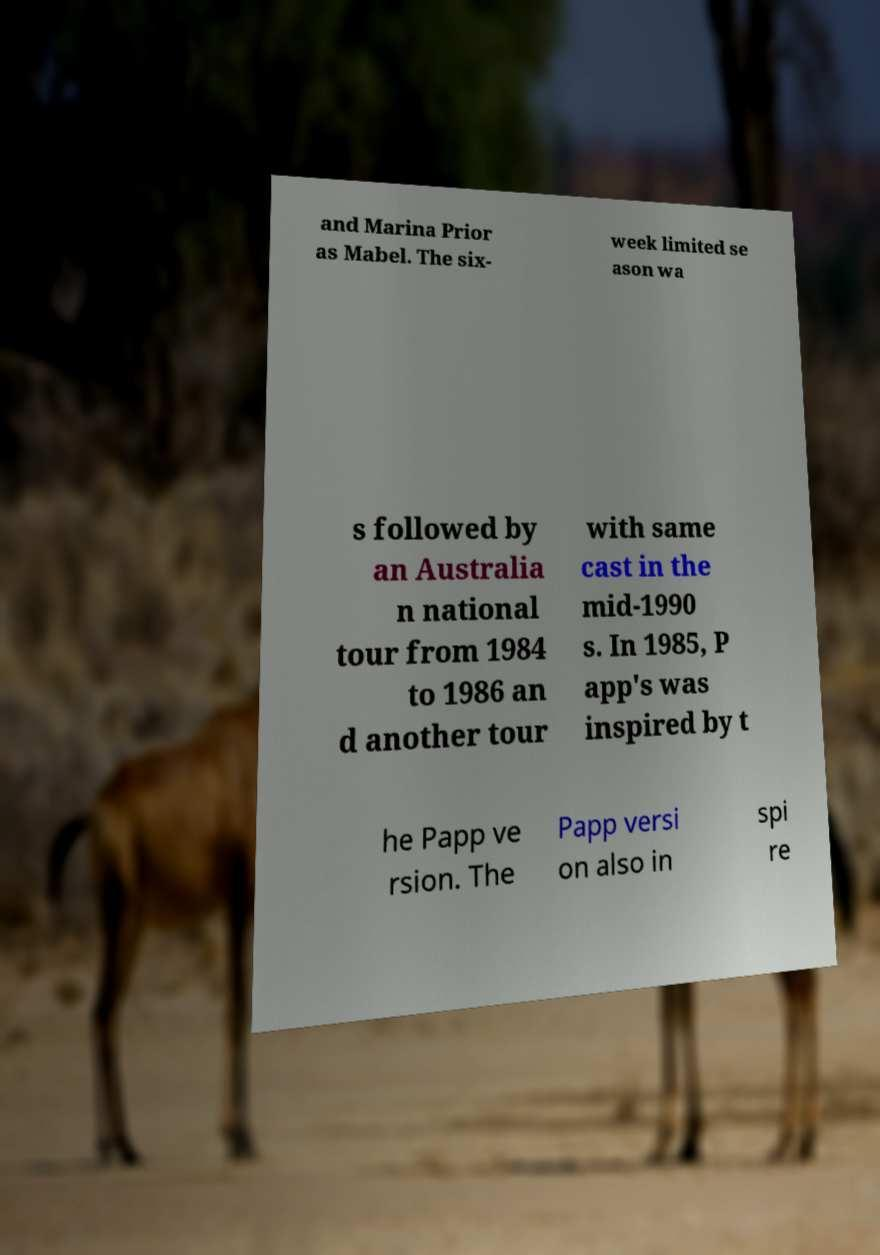What messages or text are displayed in this image? I need them in a readable, typed format. and Marina Prior as Mabel. The six- week limited se ason wa s followed by an Australia n national tour from 1984 to 1986 an d another tour with same cast in the mid-1990 s. In 1985, P app's was inspired by t he Papp ve rsion. The Papp versi on also in spi re 